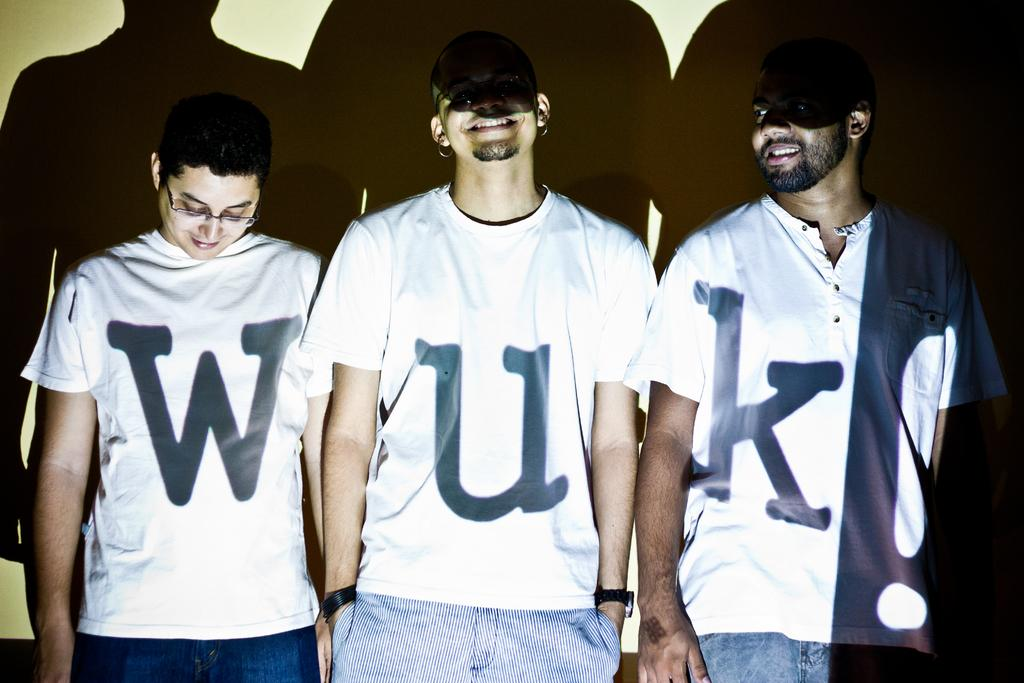<image>
Render a clear and concise summary of the photo. Three men are wearing shirts that each have a letter on them that say WUK. 